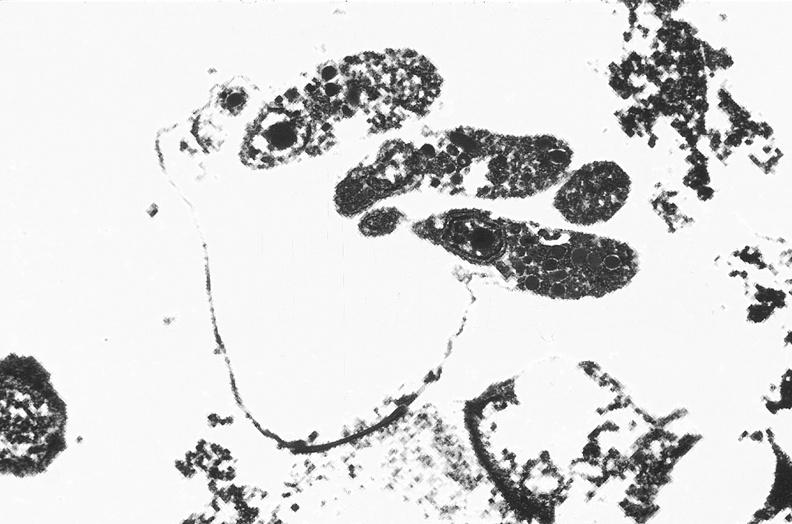s gastrointestinal present?
Answer the question using a single word or phrase. Yes 